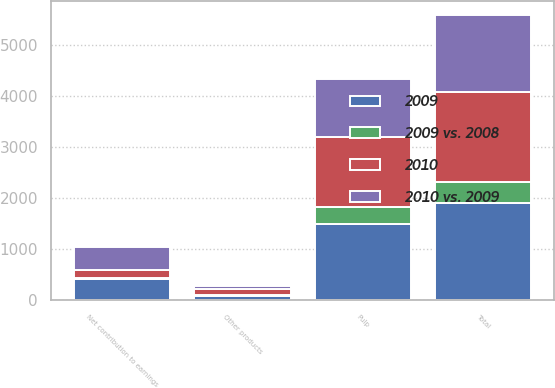<chart> <loc_0><loc_0><loc_500><loc_500><stacked_bar_chart><ecel><fcel>Pulp<fcel>Other products<fcel>Total<fcel>Net contribution to earnings<nl><fcel>2009<fcel>1489<fcel>85<fcel>1911<fcel>412<nl><fcel>2010 vs. 2009<fcel>1148<fcel>73<fcel>1511<fcel>444<nl><fcel>2010<fcel>1357<fcel>118<fcel>1765<fcel>147<nl><fcel>2009 vs. 2008<fcel>341<fcel>12<fcel>400<fcel>32<nl></chart> 